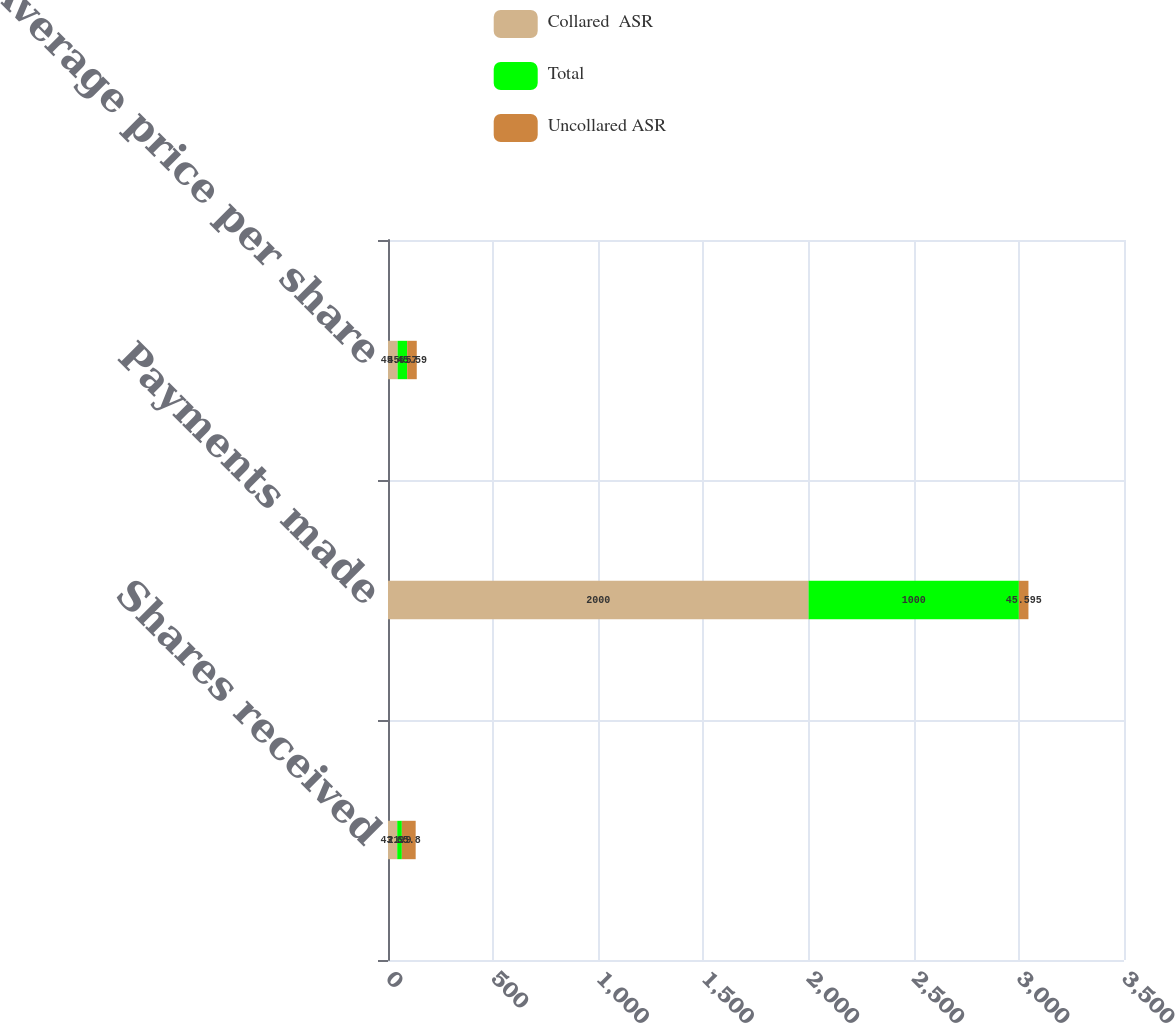<chart> <loc_0><loc_0><loc_500><loc_500><stacked_bar_chart><ecel><fcel>Shares received<fcel>Payments made<fcel>Average price per share<nl><fcel>Collared  ASR<fcel>43.9<fcel>2000<fcel>45.6<nl><fcel>Total<fcel>21.9<fcel>1000<fcel>45.57<nl><fcel>Uncollared ASR<fcel>65.8<fcel>45.595<fcel>45.59<nl></chart> 